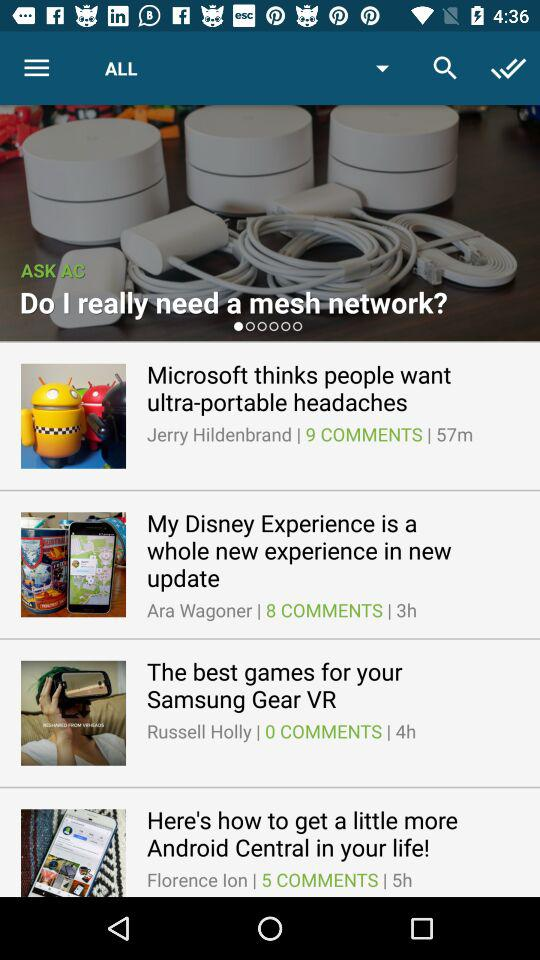What's the Published time of Microsoft thinks people want ultra portable headaches article?
When the provided information is insufficient, respond with <no answer>. <no answer> 